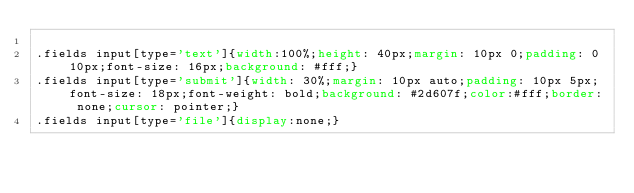<code> <loc_0><loc_0><loc_500><loc_500><_CSS_>
.fields input[type='text']{width:100%;height: 40px;margin: 10px 0;padding: 0 10px;font-size: 16px;background: #fff;}
.fields input[type='submit']{width: 30%;margin: 10px auto;padding: 10px 5px;font-size: 18px;font-weight: bold;background: #2d607f;color:#fff;border: none;cursor: pointer;}
.fields input[type='file']{display:none;}</code> 